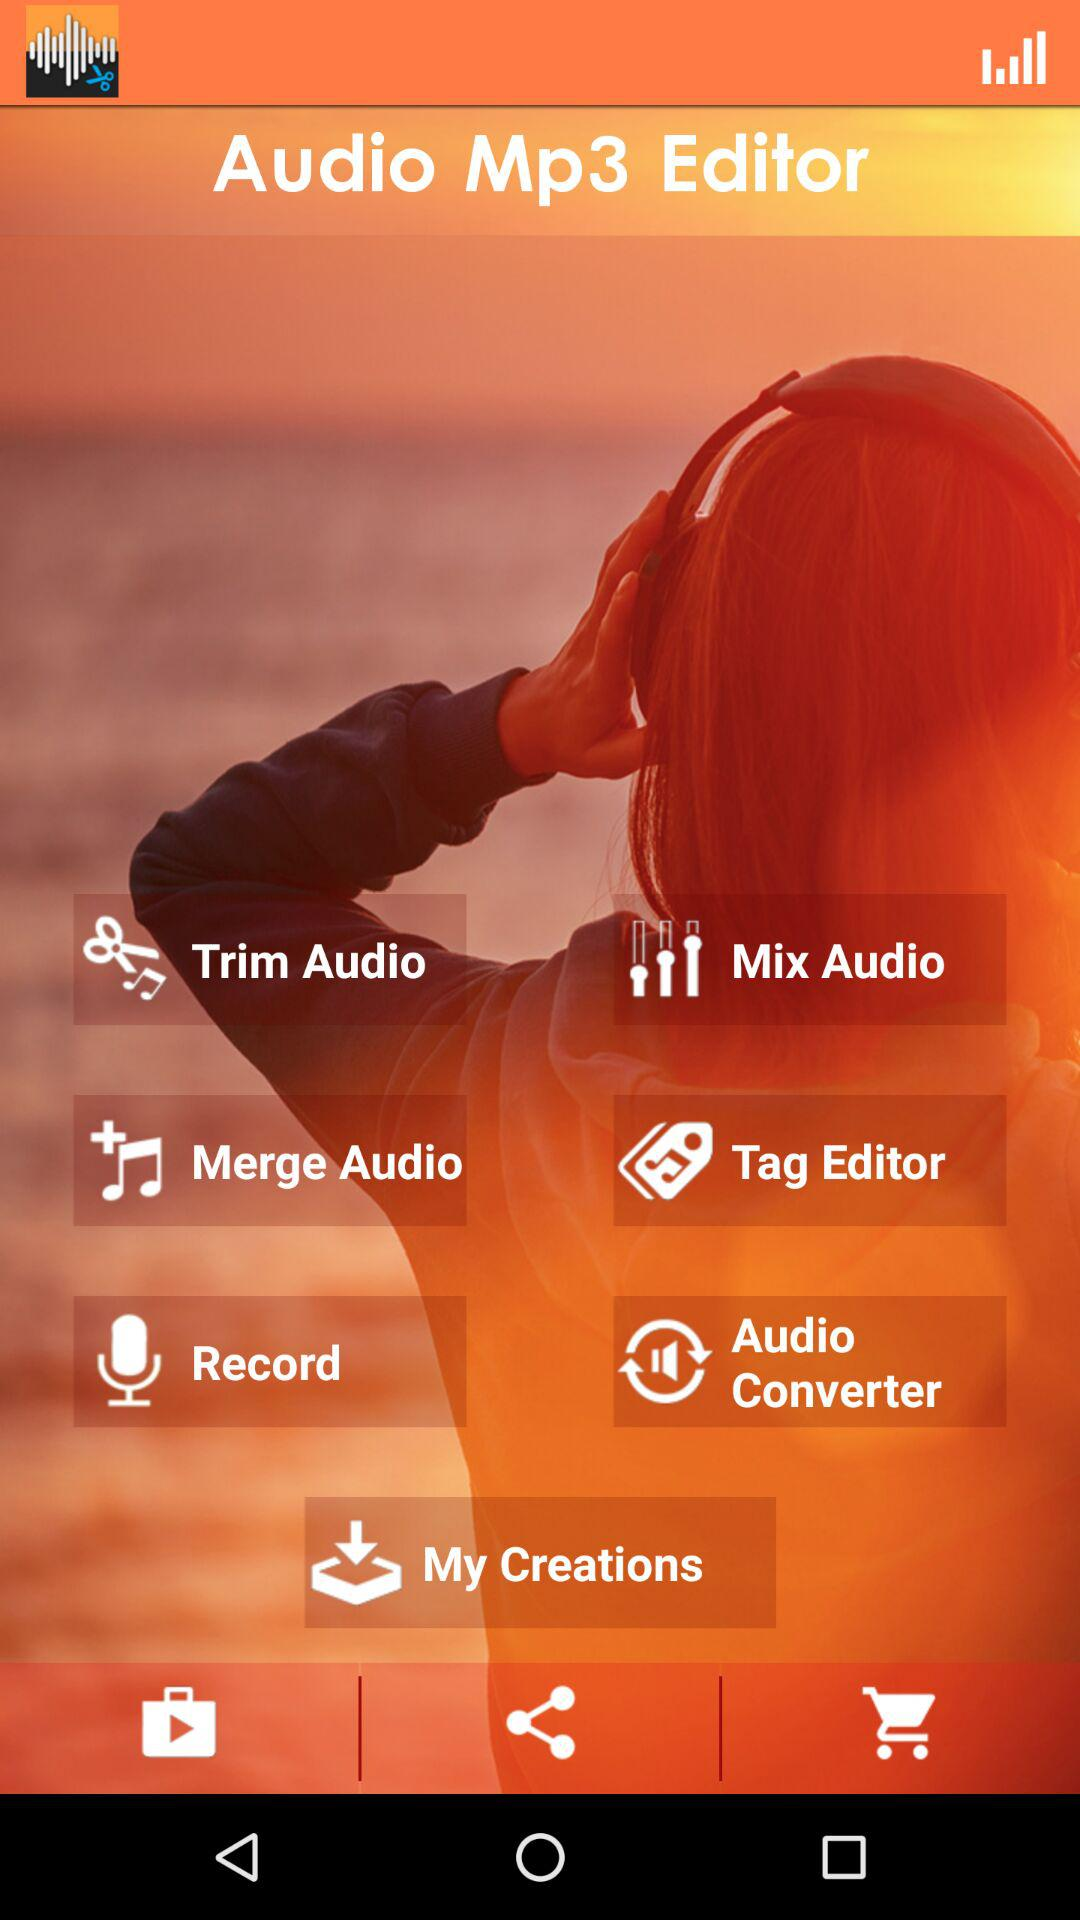What are the different features available in the "Audio Mp3 Editor"? The different features available in the "Audio Mp3 Editor" are "Trim Audio", "Mix Audio", "Merge Audio", "Tag Editor", "Record", "Audio Converter" and "My Creations". 